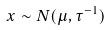Convert formula to latex. <formula><loc_0><loc_0><loc_500><loc_500>x \sim N ( \mu , \tau ^ { - 1 } )</formula> 